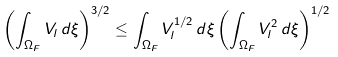<formula> <loc_0><loc_0><loc_500><loc_500>\left ( \int _ { \Omega _ { F } } V _ { l } \, d \xi \right ) ^ { 3 / 2 } \leq \int _ { \Omega _ { F } } V _ { l } ^ { 1 / 2 } \, d \xi \left ( \int _ { \Omega _ { F } } V _ { l } ^ { 2 } \, d \xi \right ) ^ { 1 / 2 }</formula> 